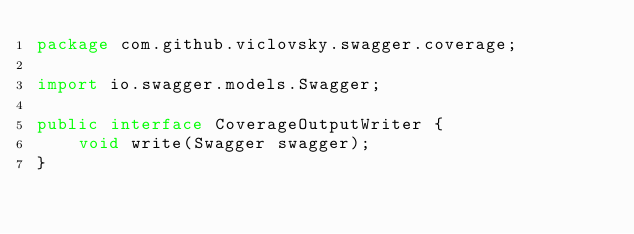<code> <loc_0><loc_0><loc_500><loc_500><_Java_>package com.github.viclovsky.swagger.coverage;

import io.swagger.models.Swagger;

public interface CoverageOutputWriter {
    void write(Swagger swagger);
}
</code> 